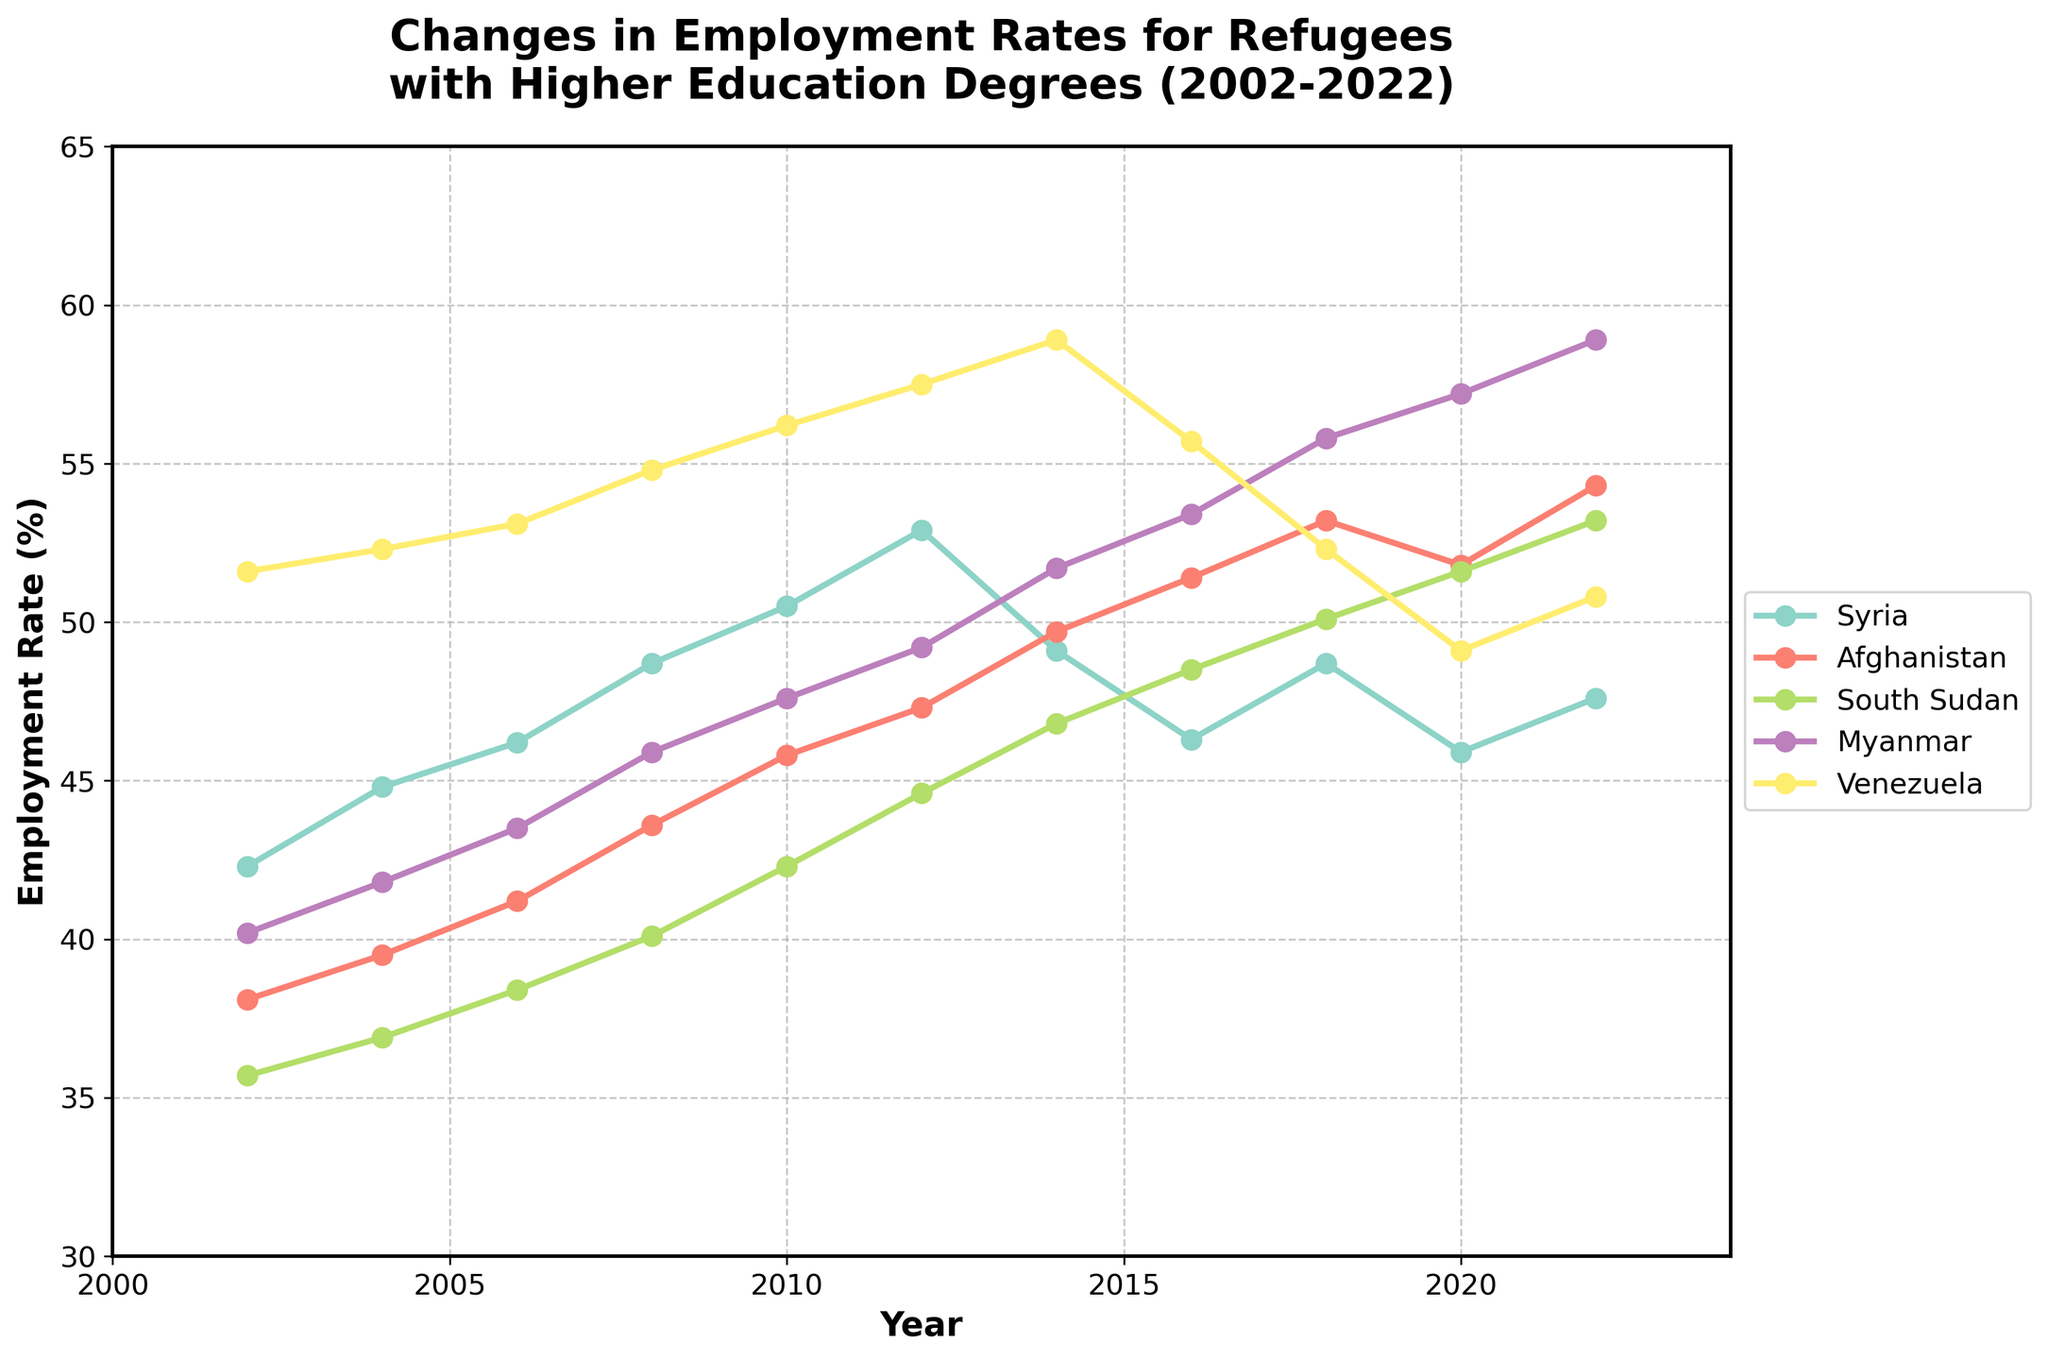What is the overall trend in employment rates for refugees from Venezuela between 2002 and 2022? Observing the line for Venezuela from 2002 to 2022, the employment rate mostly increased, reaching its peak in around 2014-2016 before declining slightly towards 2020, and then modestly rising again by 2022.
Answer: Increasing, with some fluctuations By how much did the employment rate for refugees from Afghanistan change from 2002 to 2022? Referring to the points for Afghanistan in 2002 and 2022, subtract the value in 2002 (38.1%) from the value in 2022 (54.3%) to find the difference.
Answer: 16.2% Which country had the highest employment rate in 2022? Look at the employment rates for all countries in 2022 and identify the highest value. Myanmar had the highest employment rate of 58.9%.
Answer: Myanmar In which year did Syria have its highest employment rate within the given timeframe, and what was the rate? Find the peak value along the Syrian line and identify the corresponding year, which is around 2012 with an employment rate of 52.9%.
Answer: 2012, 52.9% What is the difference in employment rates between South Sudan and Myanmar in 2018? Locate the values for South Sudan (50.1%) and Myanmar (55.8%) in 2018 and subtract the smaller from the larger value.
Answer: 5.7% Which country showed the greatest increase in employment rate between 2002 and 2012? Calculate the difference in employment rates between 2002 and 2012 for each country; Afghanistan increased by 9.2%, South Sudan by 8.9%, Myanmar by 9.0%, and Venezuela by 5.9%, with Syria showing an increase of 10.6%. Therefore, Syria showed the greatest increase.
Answer: Syria Identify the countries where the employment rate has dipped from any year’s peak within the 2002-2022 period. Compare the peak values and subsequent values for all countries. Syria peaked in 2012 and dipped afterward; Venezuela also peaked around 2014-2016 and then dropped.
Answer: Syria, Venezuela On average, how much did Myanmar’s employment rate change every two years from 2002 to 2022? First, calculate the total change from 2002 (40.2) to 2022 (58.9), which is 18.7. Then, divide this by the number of two-year periods (10) to get the average change per period.
Answer: 1.87% Which country had the steadiest increase in employment rates from 2002 to 2018? Examine all countries' lines for smooth, consistent upward trends. Afghanistan and Myanmar both show steady increases, but Myanmar had less fluctuation.
Answer: Myanmar 